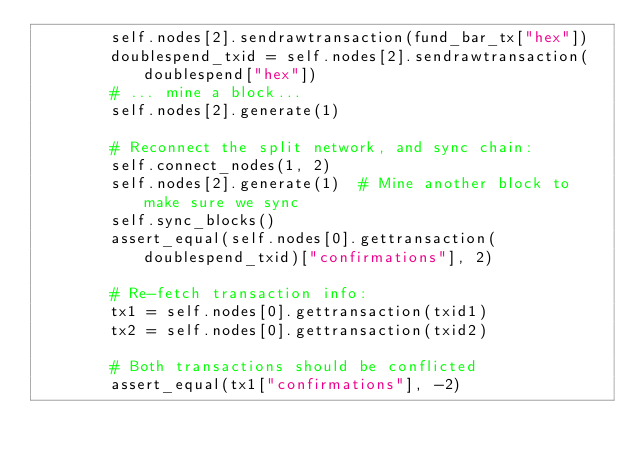Convert code to text. <code><loc_0><loc_0><loc_500><loc_500><_Python_>        self.nodes[2].sendrawtransaction(fund_bar_tx["hex"])
        doublespend_txid = self.nodes[2].sendrawtransaction(doublespend["hex"])
        # ... mine a block...
        self.nodes[2].generate(1)

        # Reconnect the split network, and sync chain:
        self.connect_nodes(1, 2)
        self.nodes[2].generate(1)  # Mine another block to make sure we sync
        self.sync_blocks()
        assert_equal(self.nodes[0].gettransaction(doublespend_txid)["confirmations"], 2)

        # Re-fetch transaction info:
        tx1 = self.nodes[0].gettransaction(txid1)
        tx2 = self.nodes[0].gettransaction(txid2)

        # Both transactions should be conflicted
        assert_equal(tx1["confirmations"], -2)</code> 